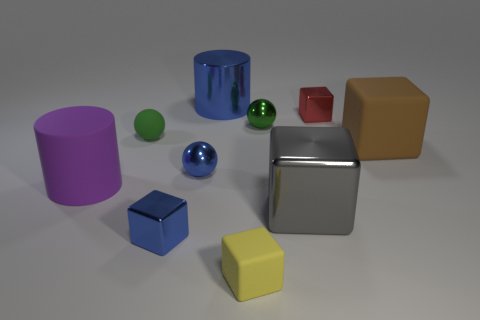How many tiny objects are metallic objects or brown rubber blocks?
Make the answer very short. 4. What color is the metal cylinder that is the same size as the purple thing?
Make the answer very short. Blue. What number of large gray cubes are to the right of the tiny yellow rubber thing?
Provide a short and direct response. 1. Are there any big gray objects made of the same material as the tiny yellow cube?
Your answer should be very brief. No. What is the shape of the tiny shiny object that is the same color as the small matte sphere?
Provide a succinct answer. Sphere. What color is the big matte object left of the large blue shiny cylinder?
Offer a terse response. Purple. Are there an equal number of large metal blocks that are in front of the small yellow cube and large objects that are left of the small red block?
Provide a succinct answer. No. There is a large object in front of the large rubber thing left of the tiny yellow cube; what is it made of?
Your response must be concise. Metal. What number of things are either cyan spheres or tiny blue shiny things behind the purple rubber thing?
Provide a short and direct response. 1. What is the size of the gray thing that is made of the same material as the red thing?
Your answer should be compact. Large. 